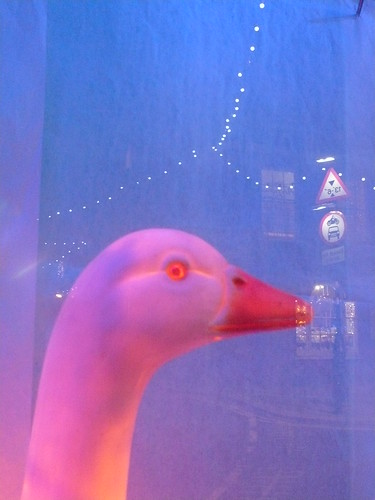What age group might this toy be targeted towards, and why? This toy seems targeted towards younger children, possibly in the preschool to early elementary range. The realistic, yet approachable and harmless depiction of the goose makes it suitable for young kids. The size and simplicity of design also cater to this age group's needs for safe and tangible engagement. 